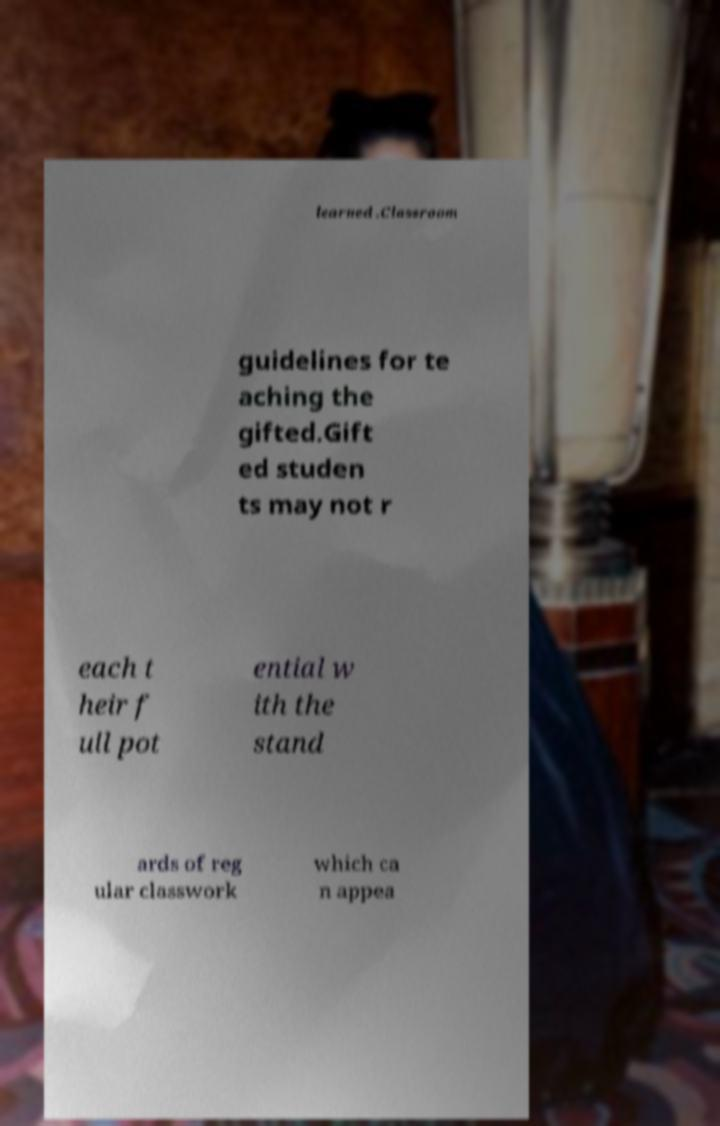Please read and relay the text visible in this image. What does it say? learned .Classroom guidelines for te aching the gifted.Gift ed studen ts may not r each t heir f ull pot ential w ith the stand ards of reg ular classwork which ca n appea 